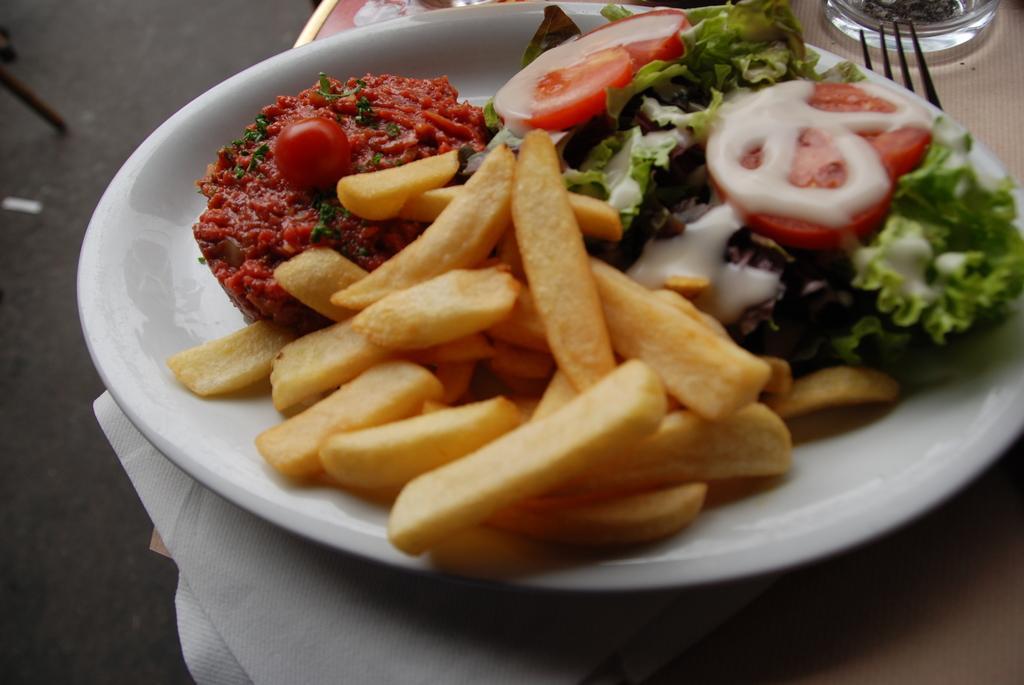Could you give a brief overview of what you see in this image? In the image I can see a plate in which there are some fries, chopped tomatoes and some leafy vegetable and to the side there is a fork. 